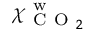<formula> <loc_0><loc_0><loc_500><loc_500>\chi _ { C O _ { 2 } } ^ { w }</formula> 